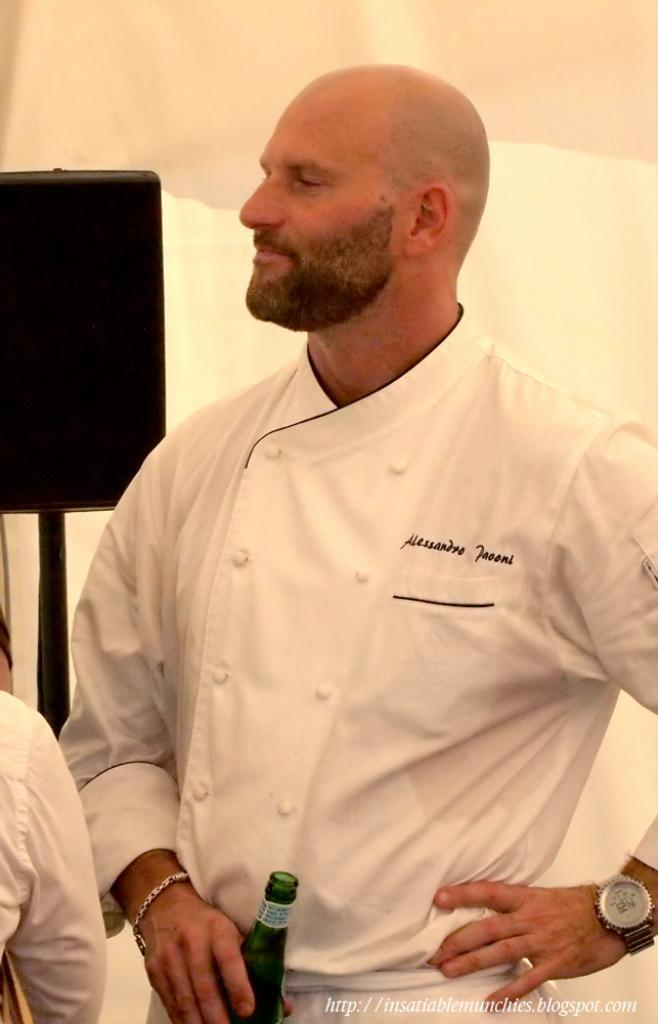<image>
Create a compact narrative representing the image presented. A chef drinking a beer with the name Alessandro Jaooni on it 